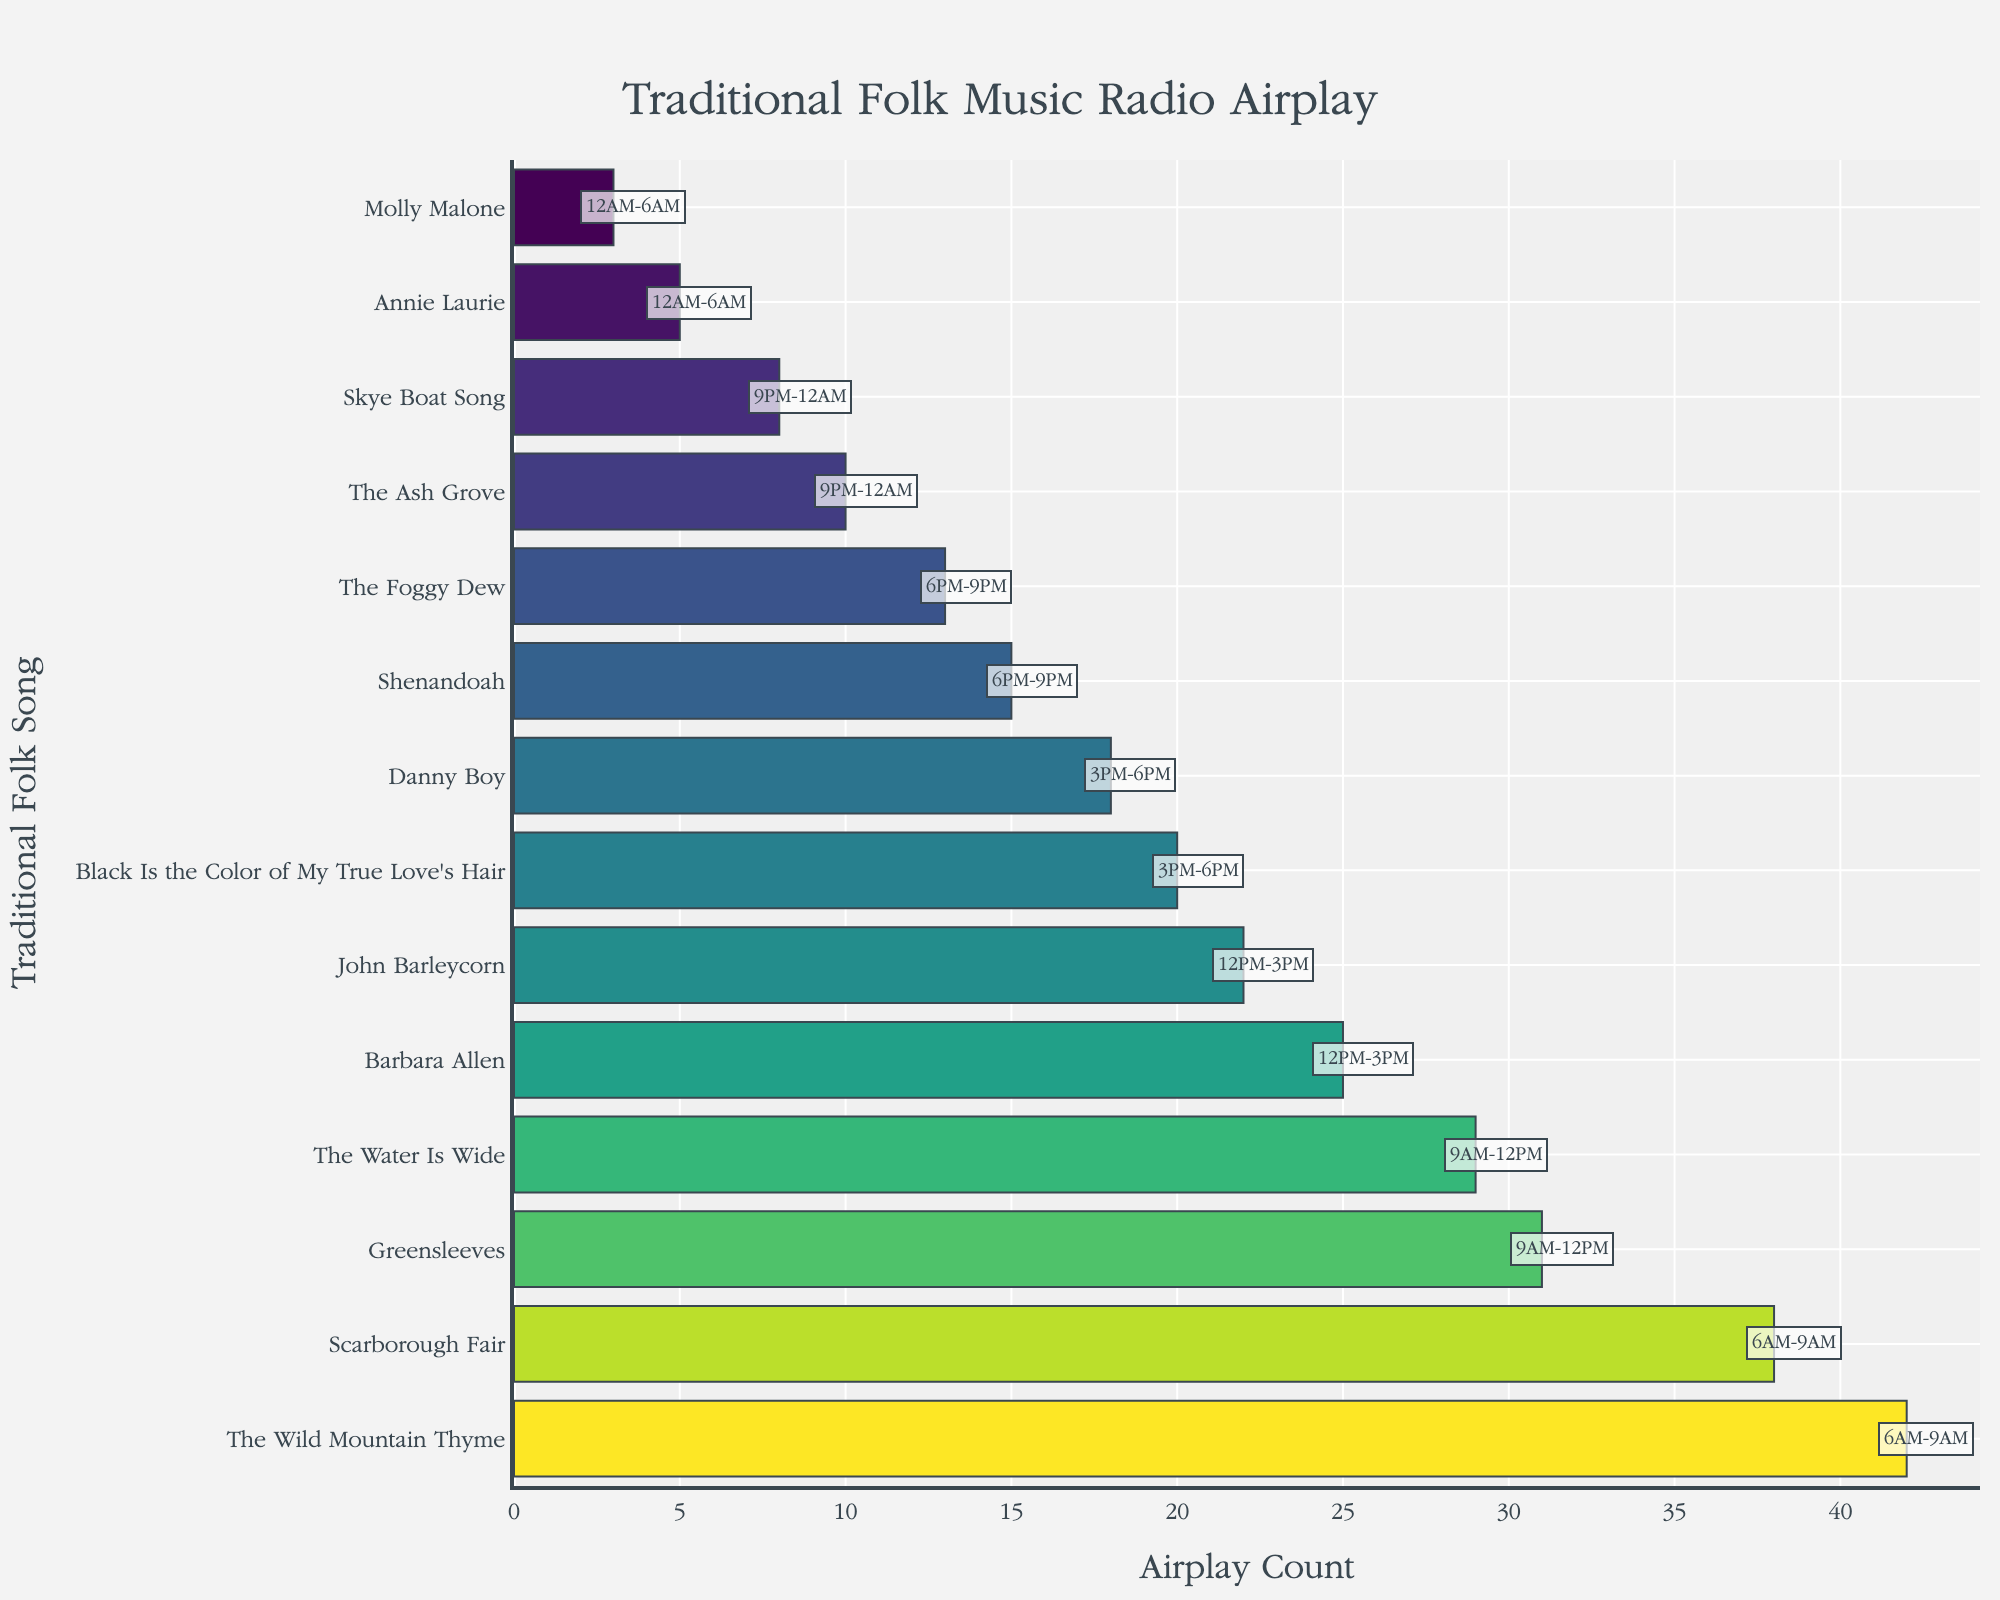What's the title of the plot? At the top center of the plot, it is labeled "Traditional Folk Music Radio Airplay".
Answer: Traditional Folk Music Radio Airplay Which folk song has the highest airplay count? The longest bar in the plot represents "The Wild Mountain Thyme" with the highest x-value.
Answer: The Wild Mountain Thyme What is the airplay count for "Danny Boy"? Find the bar representing "Danny Boy" and note the value on the x-axis.
Answer: 18 During which time slot is "Greensleeves" played the most? Look for the annotation next to the "Greensleeves" bar, which indicates its time slot.
Answer: 9AM-12PM What is the total airplay count for songs played between 12AM to 6AM? Sum the airplay counts for "Annie Laurie" and "Molly Malone" from the 12AM to 6AM slot. 5 + 3 = 8
Answer: 8 Which song is played least during the 3PM-6PM time slot? Compare the airplay counts of songs played between 3PM-6PM, focusing on the shorter bar between "Black Is the Color of My True Love's Hair" and "Danny Boy".
Answer: Danny Boy How many songs have an airplay count of below 20? Count the bars with x-values less than 20.
Answer: 7 Are there more songs played between 6AM-9AM than between 9PM-12AM? Count the songs in each time slot and compare. Six songs are in the 6AM-9AM slot while two are in the 9PM-12AM slot.
Answer: Yes What is the median airplay count of all the songs? List the airplay counts in ascending order (3, 5, 8, 10, 13, 15, 18, 20, 22, 25, 29, 31, 38, 42) and find the middle value. The middle values are 18 and 20, so the median is (18 + 20) / 2 = 19.
Answer: 19 Which time slot features the song with the highest airplay count? Locate the bar with the highest airplay count and note the time slot annotation next to it.
Answer: 6AM-9AM 